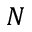Convert formula to latex. <formula><loc_0><loc_0><loc_500><loc_500>N</formula> 